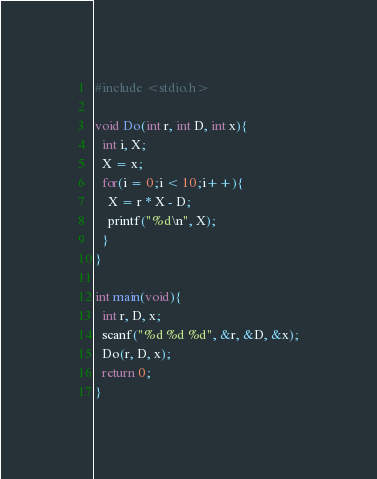Convert code to text. <code><loc_0><loc_0><loc_500><loc_500><_C_>#include <stdio.h>

void Do(int r, int D, int x){
  int i, X;
  X = x;
  for(i = 0;i < 10;i++){
    X = r * X - D;
    printf("%d\n", X);
  }
}

int main(void){
  int r, D, x;
  scanf("%d %d %d", &r, &D, &x);
  Do(r, D, x);
  return 0;
}
</code> 